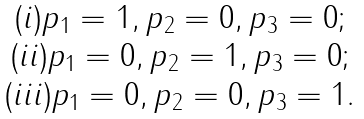Convert formula to latex. <formula><loc_0><loc_0><loc_500><loc_500>\begin{array} { c } ( i ) p _ { 1 } = 1 , p _ { 2 } = 0 , p _ { 3 } = 0 ; \\ ( i i ) p _ { 1 } = 0 , p _ { 2 } = 1 , p _ { 3 } = 0 ; \\ ( i i i ) p _ { 1 } = 0 , p _ { 2 } = 0 , p _ { 3 } = 1 . \end{array}</formula> 